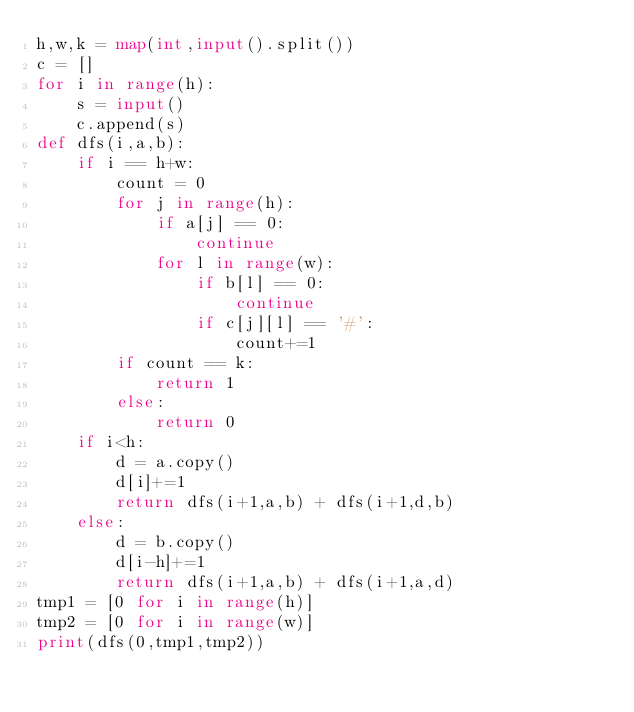<code> <loc_0><loc_0><loc_500><loc_500><_Python_>h,w,k = map(int,input().split())
c = []
for i in range(h):
    s = input()
    c.append(s)
def dfs(i,a,b):
    if i == h+w:
        count = 0
        for j in range(h):
            if a[j] == 0:
                continue
            for l in range(w):
                if b[l] == 0:
                    continue
                if c[j][l] == '#':
                    count+=1
        if count == k:
            return 1
        else:
            return 0
    if i<h:
        d = a.copy()
        d[i]+=1
        return dfs(i+1,a,b) + dfs(i+1,d,b)
    else:
        d = b.copy()
        d[i-h]+=1
        return dfs(i+1,a,b) + dfs(i+1,a,d)
tmp1 = [0 for i in range(h)]
tmp2 = [0 for i in range(w)]
print(dfs(0,tmp1,tmp2))</code> 